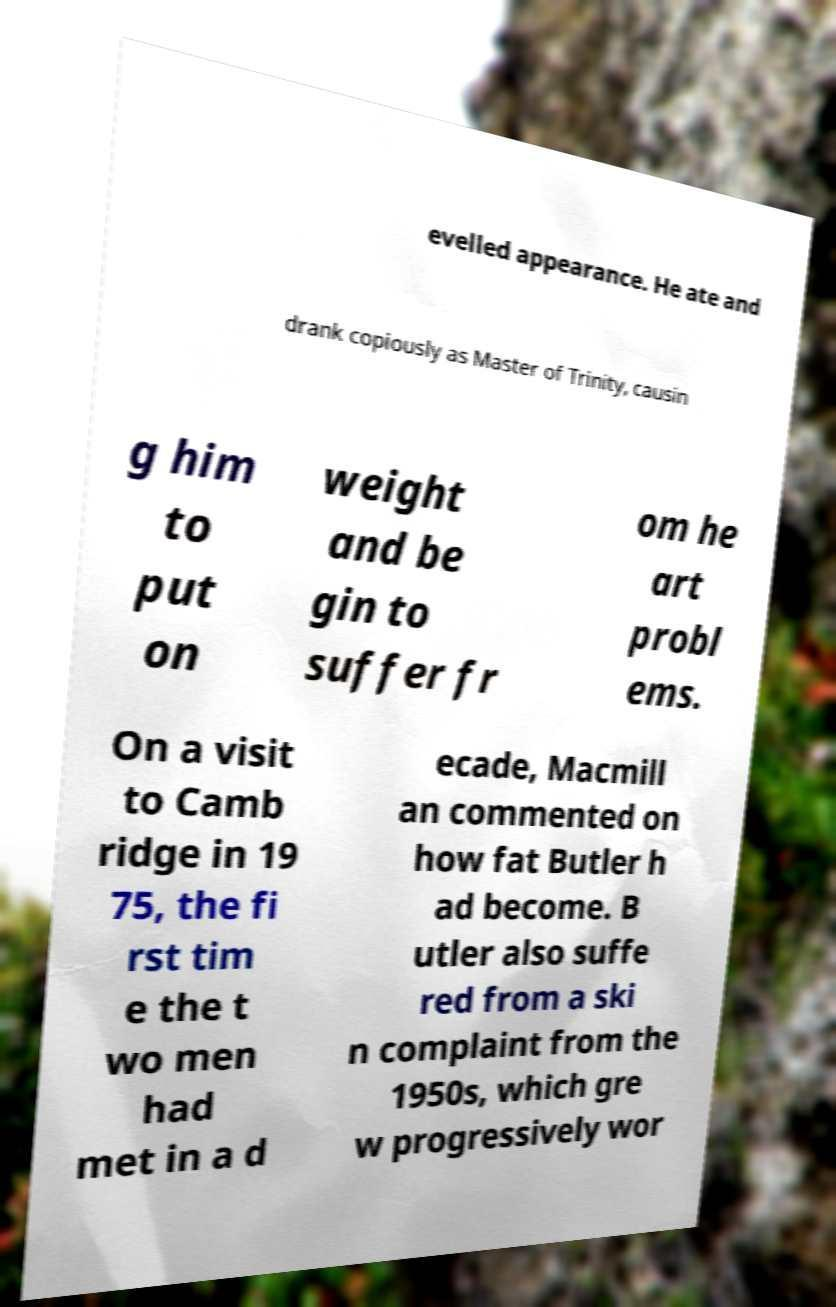Can you accurately transcribe the text from the provided image for me? evelled appearance. He ate and drank copiously as Master of Trinity, causin g him to put on weight and be gin to suffer fr om he art probl ems. On a visit to Camb ridge in 19 75, the fi rst tim e the t wo men had met in a d ecade, Macmill an commented on how fat Butler h ad become. B utler also suffe red from a ski n complaint from the 1950s, which gre w progressively wor 